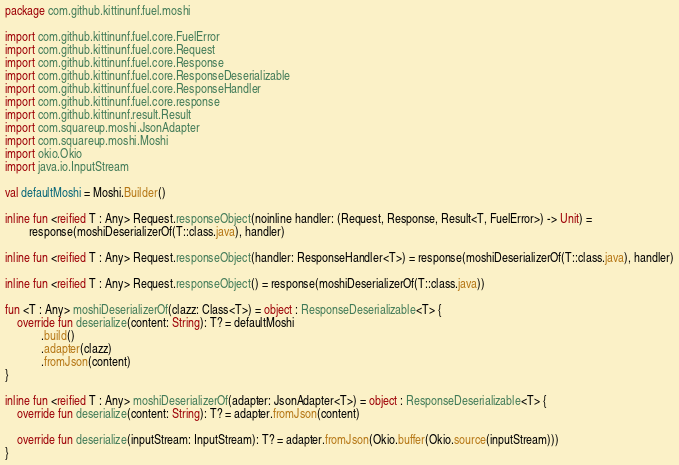<code> <loc_0><loc_0><loc_500><loc_500><_Kotlin_>package com.github.kittinunf.fuel.moshi

import com.github.kittinunf.fuel.core.FuelError
import com.github.kittinunf.fuel.core.Request
import com.github.kittinunf.fuel.core.Response
import com.github.kittinunf.fuel.core.ResponseDeserializable
import com.github.kittinunf.fuel.core.ResponseHandler
import com.github.kittinunf.fuel.core.response
import com.github.kittinunf.result.Result
import com.squareup.moshi.JsonAdapter
import com.squareup.moshi.Moshi
import okio.Okio
import java.io.InputStream

val defaultMoshi = Moshi.Builder()

inline fun <reified T : Any> Request.responseObject(noinline handler: (Request, Response, Result<T, FuelError>) -> Unit) =
        response(moshiDeserializerOf(T::class.java), handler)

inline fun <reified T : Any> Request.responseObject(handler: ResponseHandler<T>) = response(moshiDeserializerOf(T::class.java), handler)

inline fun <reified T : Any> Request.responseObject() = response(moshiDeserializerOf(T::class.java))

fun <T : Any> moshiDeserializerOf(clazz: Class<T>) = object : ResponseDeserializable<T> {
    override fun deserialize(content: String): T? = defaultMoshi
            .build()
            .adapter(clazz)
            .fromJson(content)
}

inline fun <reified T : Any> moshiDeserializerOf(adapter: JsonAdapter<T>) = object : ResponseDeserializable<T> {
    override fun deserialize(content: String): T? = adapter.fromJson(content)

    override fun deserialize(inputStream: InputStream): T? = adapter.fromJson(Okio.buffer(Okio.source(inputStream)))
}
</code> 